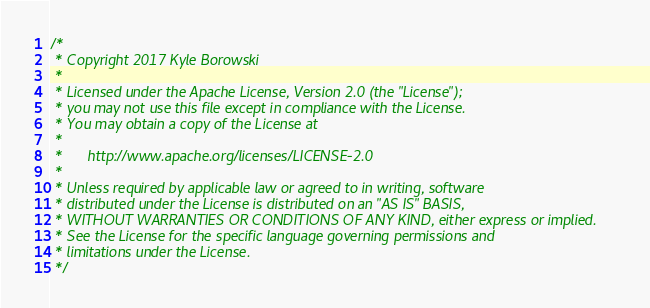Convert code to text. <code><loc_0><loc_0><loc_500><loc_500><_Java_>/*
 * Copyright 2017 Kyle Borowski
 *
 * Licensed under the Apache License, Version 2.0 (the "License");
 * you may not use this file except in compliance with the License.
 * You may obtain a copy of the License at
 *
 *      http://www.apache.org/licenses/LICENSE-2.0
 *
 * Unless required by applicable law or agreed to in writing, software
 * distributed under the License is distributed on an "AS IS" BASIS,
 * WITHOUT WARRANTIES OR CONDITIONS OF ANY KIND, either express or implied.
 * See the License for the specific language governing permissions and
 * limitations under the License.
 */</code> 